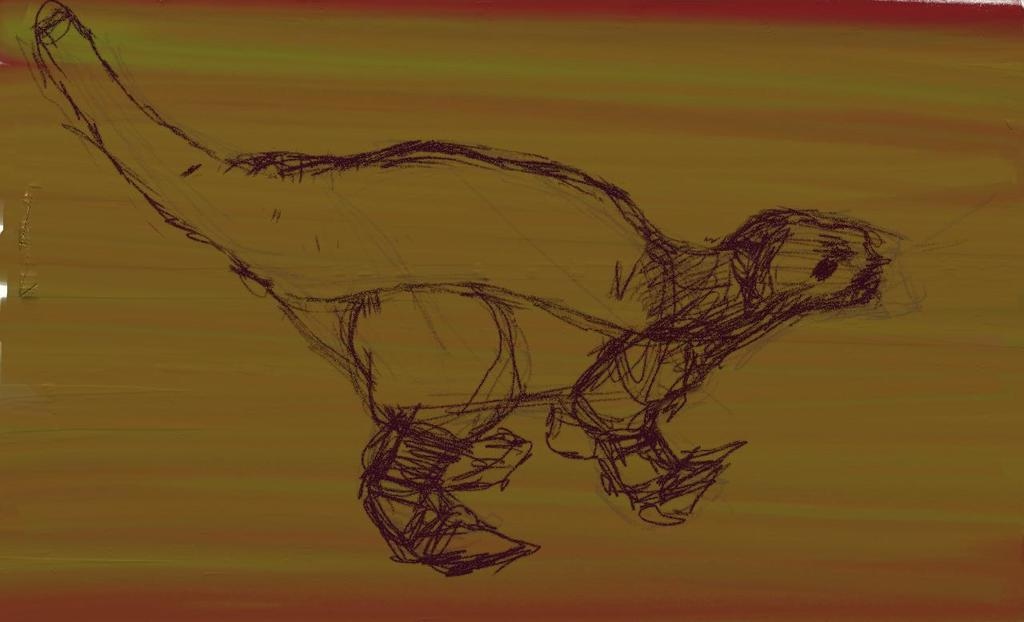What type of artwork is shown in the image? The image is a drawing. What is the subject of the drawing? The drawing depicts an animal. On what surface is the drawing made? The drawing is on a wooden surface. How many sheep are visible in the drawing? There are no sheep present in the drawing; it depicts an animal, but not specifically a sheep. 